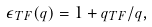Convert formula to latex. <formula><loc_0><loc_0><loc_500><loc_500>\epsilon _ { T F } ( q ) = 1 + q _ { T F } / q ,</formula> 